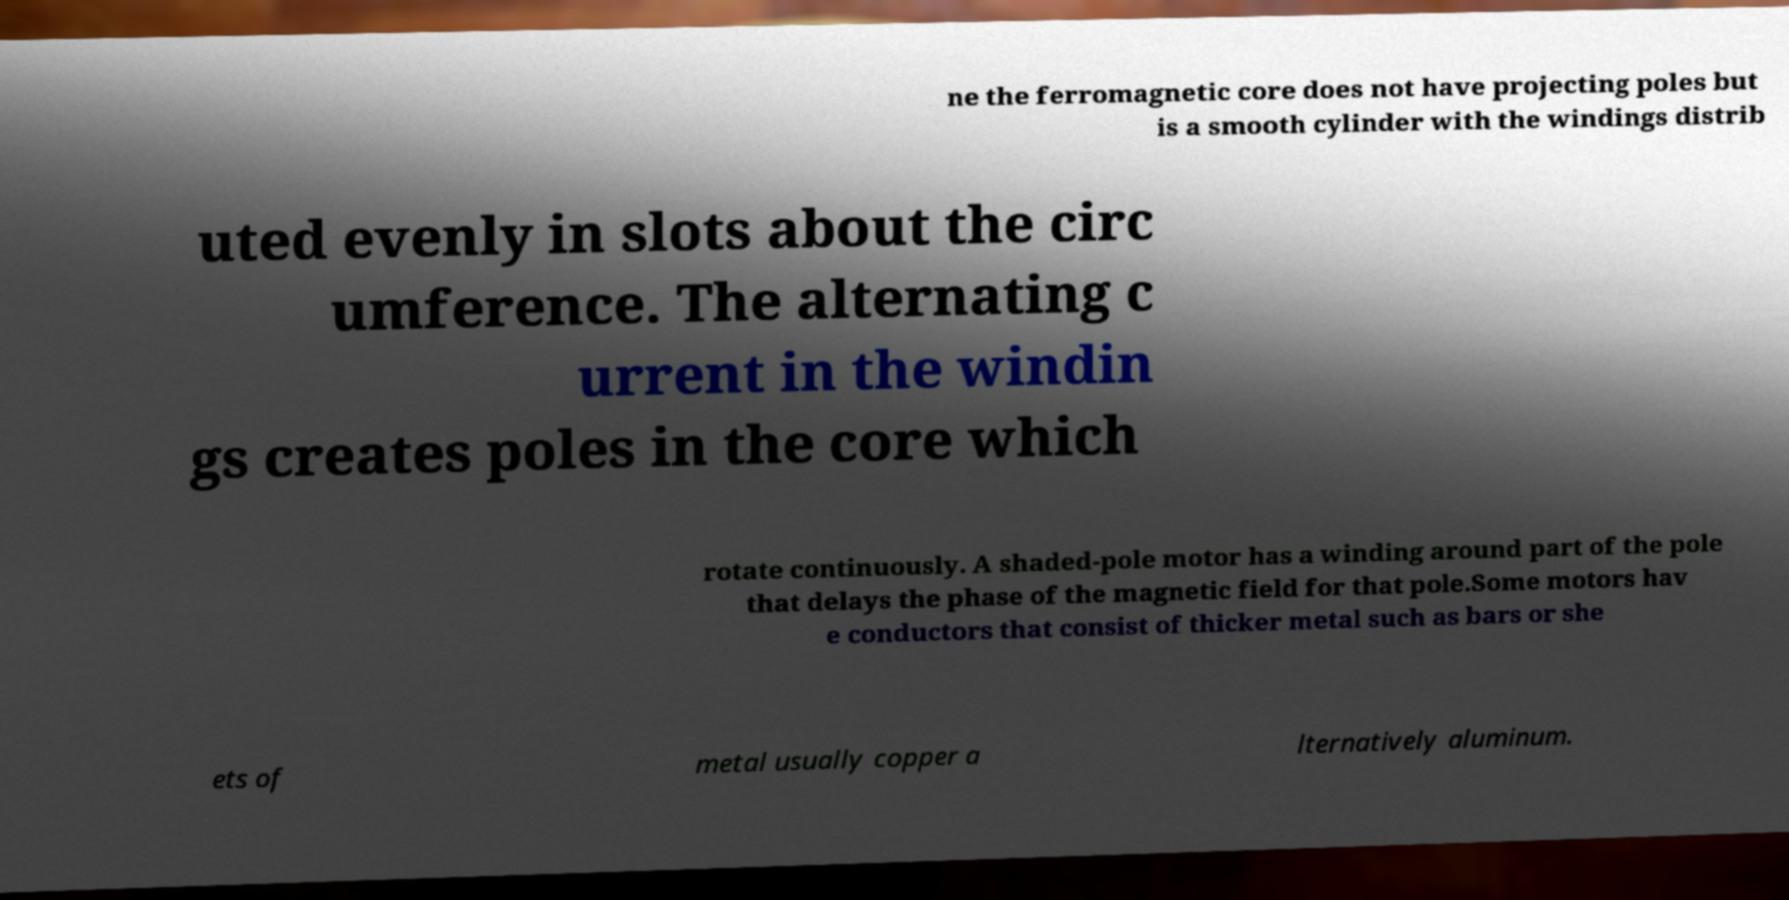I need the written content from this picture converted into text. Can you do that? ne the ferromagnetic core does not have projecting poles but is a smooth cylinder with the windings distrib uted evenly in slots about the circ umference. The alternating c urrent in the windin gs creates poles in the core which rotate continuously. A shaded-pole motor has a winding around part of the pole that delays the phase of the magnetic field for that pole.Some motors hav e conductors that consist of thicker metal such as bars or she ets of metal usually copper a lternatively aluminum. 